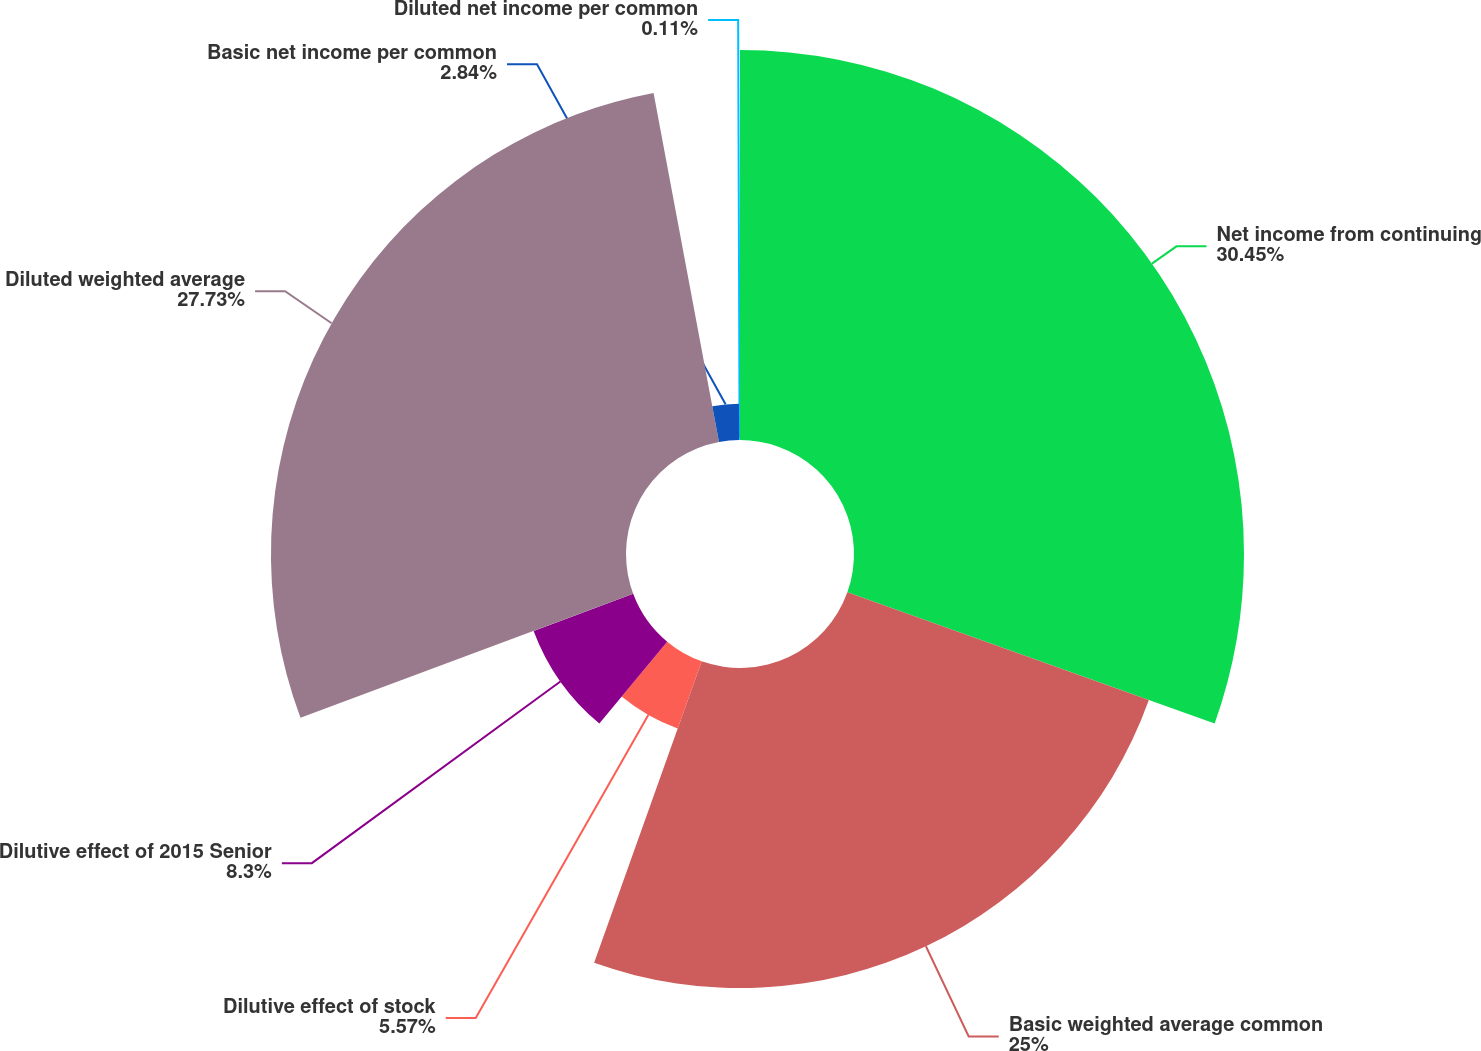<chart> <loc_0><loc_0><loc_500><loc_500><pie_chart><fcel>Net income from continuing<fcel>Basic weighted average common<fcel>Dilutive effect of stock<fcel>Dilutive effect of 2015 Senior<fcel>Diluted weighted average<fcel>Basic net income per common<fcel>Diluted net income per common<nl><fcel>30.46%<fcel>25.0%<fcel>5.57%<fcel>8.3%<fcel>27.73%<fcel>2.84%<fcel>0.11%<nl></chart> 